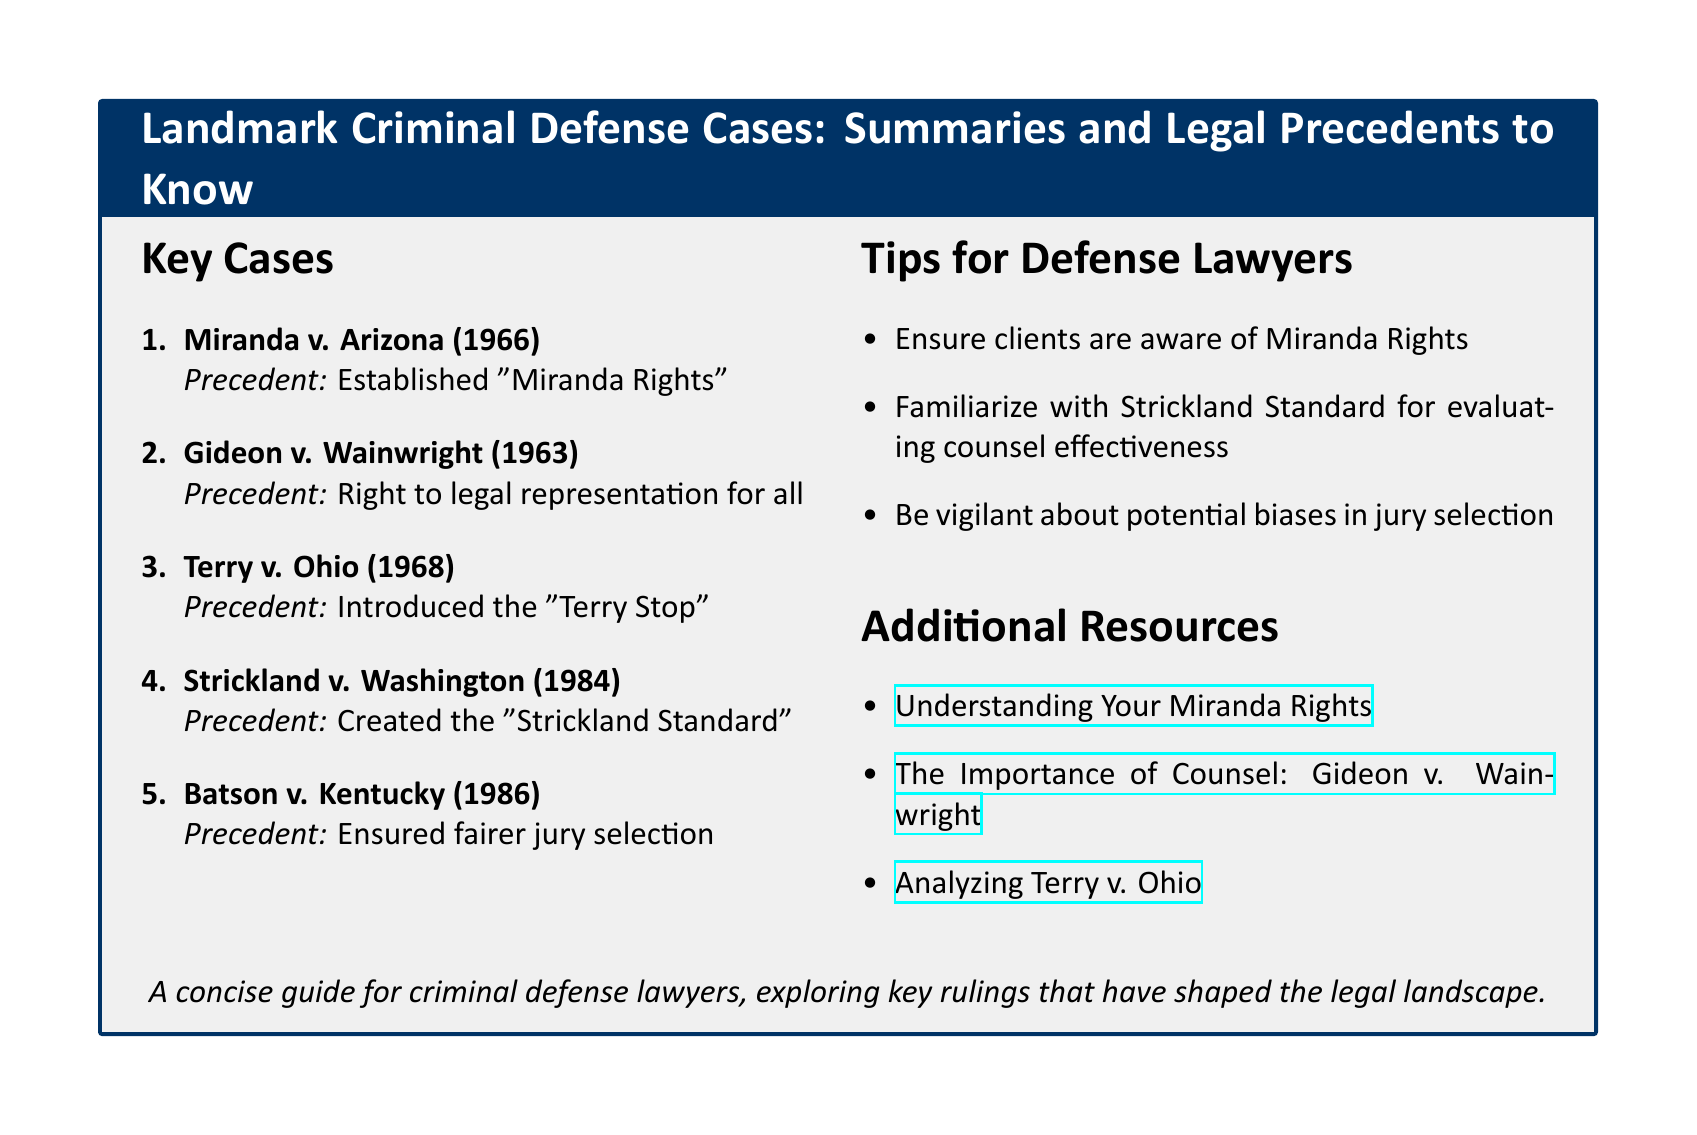What is the title of the document? The title is provided at the top of the tcolorbox.
Answer: Landmark Criminal Defense Cases: Summaries and Legal Precedents to Know How many key cases are listed? The number of key cases can be counted from the enumeration.
Answer: 5 What precedent was established in Gideon v. Wainwright? This precedent is stated right after the case title.
Answer: Right to legal representation for all What is the Strickland Standard? This refers to the precedent created in Strickland v. Washington, which is mentioned under the key cases.
Answer: Created the "Strickland Standard" What should defense lawyers ensure clients are aware of? This tip is listed under the Tips for Defense Lawyers section.
Answer: Miranda Rights Which case introduced the "Terry Stop"? The introduction of the "Terry Stop" is stated instantly after the case name in the document.
Answer: Terry v. Ohio What is one of the resources provided for understanding Miranda Rights? The specific resource is linked in the Additional Resources section.
Answer: Understanding Your Miranda Rights What important aspect should lawyers be vigilant about in jury selection? This is a tip mentioned in the document aimed at defense lawyers.
Answer: Potential biases 